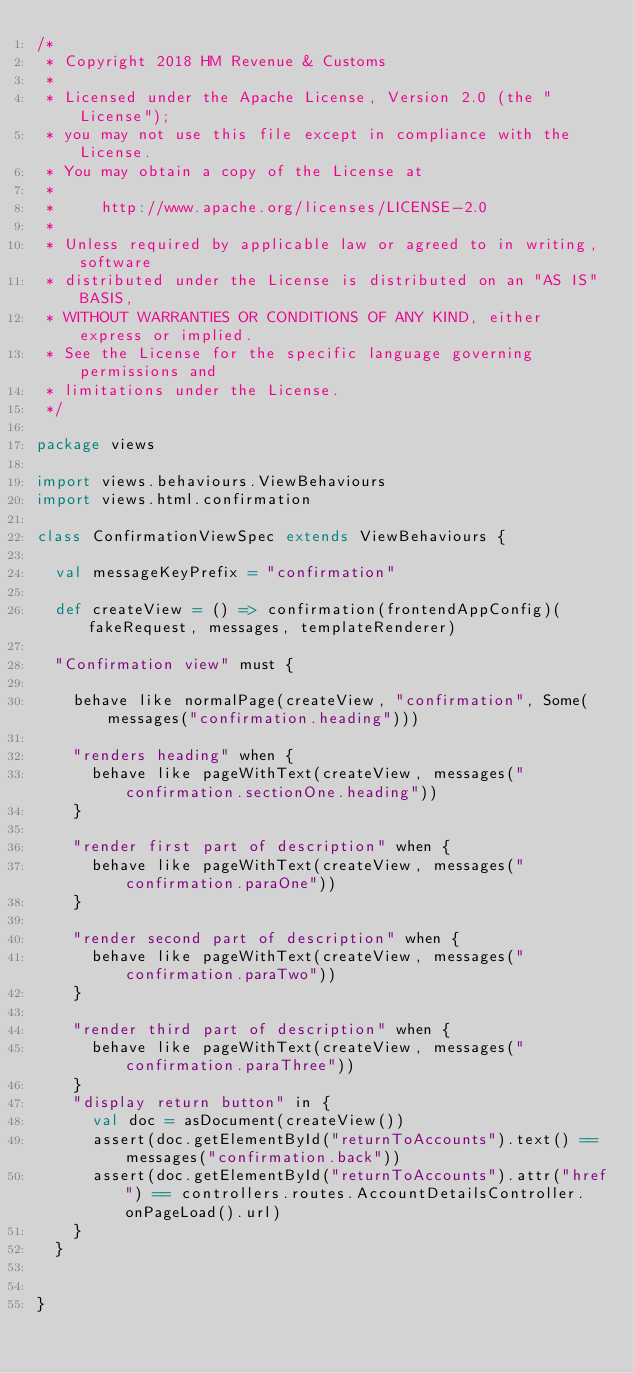Convert code to text. <code><loc_0><loc_0><loc_500><loc_500><_Scala_>/*
 * Copyright 2018 HM Revenue & Customs
 *
 * Licensed under the Apache License, Version 2.0 (the "License");
 * you may not use this file except in compliance with the License.
 * You may obtain a copy of the License at
 *
 *     http://www.apache.org/licenses/LICENSE-2.0
 *
 * Unless required by applicable law or agreed to in writing, software
 * distributed under the License is distributed on an "AS IS" BASIS,
 * WITHOUT WARRANTIES OR CONDITIONS OF ANY KIND, either express or implied.
 * See the License for the specific language governing permissions and
 * limitations under the License.
 */

package views

import views.behaviours.ViewBehaviours
import views.html.confirmation

class ConfirmationViewSpec extends ViewBehaviours {

  val messageKeyPrefix = "confirmation"

  def createView = () => confirmation(frontendAppConfig)(fakeRequest, messages, templateRenderer)

  "Confirmation view" must {

    behave like normalPage(createView, "confirmation", Some(messages("confirmation.heading")))

    "renders heading" when {
      behave like pageWithText(createView, messages("confirmation.sectionOne.heading"))
    }

    "render first part of description" when {
      behave like pageWithText(createView, messages("confirmation.paraOne"))
    }

    "render second part of description" when {
      behave like pageWithText(createView, messages("confirmation.paraTwo"))
    }

    "render third part of description" when {
      behave like pageWithText(createView, messages("confirmation.paraThree"))
    }
    "display return button" in {
      val doc = asDocument(createView())
      assert(doc.getElementById("returnToAccounts").text() == messages("confirmation.back"))
      assert(doc.getElementById("returnToAccounts").attr("href") == controllers.routes.AccountDetailsController.onPageLoad().url)
    }
  }


}
</code> 